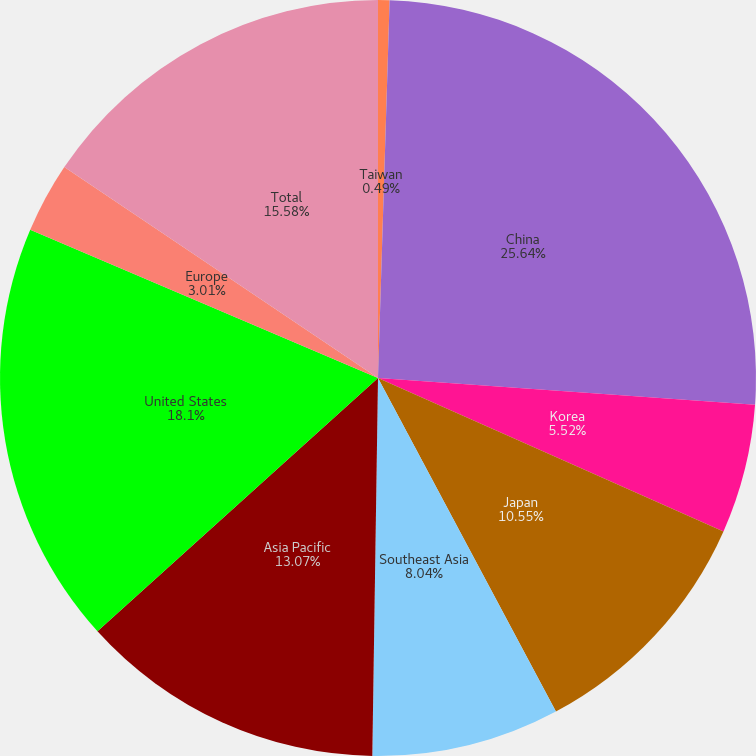<chart> <loc_0><loc_0><loc_500><loc_500><pie_chart><fcel>Taiwan<fcel>China<fcel>Korea<fcel>Japan<fcel>Southeast Asia<fcel>Asia Pacific<fcel>United States<fcel>Europe<fcel>Total<nl><fcel>0.49%<fcel>25.64%<fcel>5.52%<fcel>10.55%<fcel>8.04%<fcel>13.07%<fcel>18.1%<fcel>3.01%<fcel>15.58%<nl></chart> 